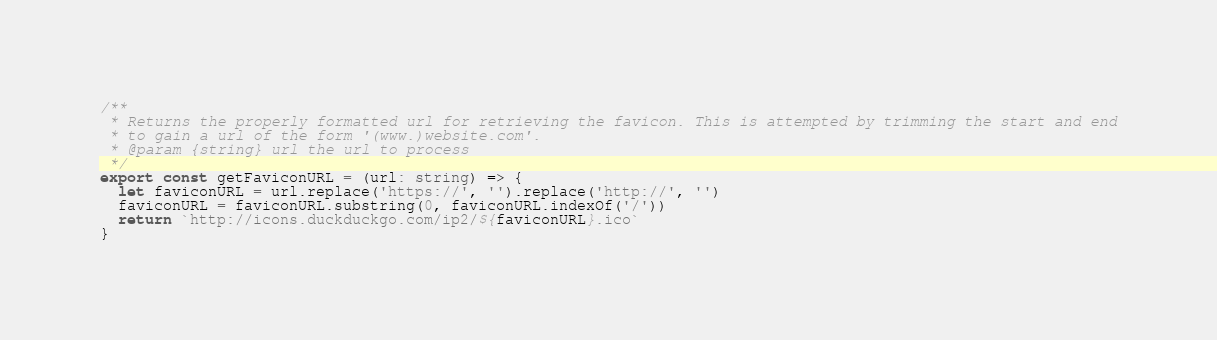Convert code to text. <code><loc_0><loc_0><loc_500><loc_500><_TypeScript_>/**
 * Returns the properly formatted url for retrieving the favicon. This is attempted by trimming the start and end
 * to gain a url of the form '(www.)website.com'.
 * @param {string} url the url to process
 */
export const getFaviconURL = (url: string) => {
  let faviconURL = url.replace('https://', '').replace('http://', '')
  faviconURL = faviconURL.substring(0, faviconURL.indexOf('/'))
  return `http://icons.duckduckgo.com/ip2/${faviconURL}.ico`
}
</code> 